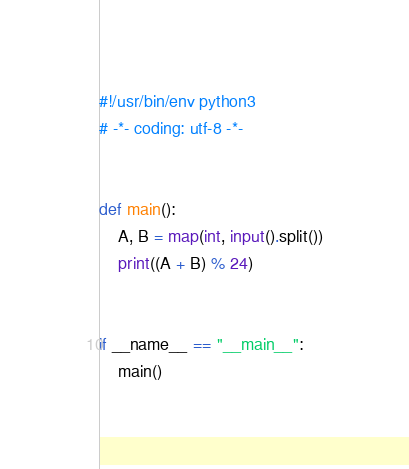<code> <loc_0><loc_0><loc_500><loc_500><_Python_>#!/usr/bin/env python3
# -*- coding: utf-8 -*-


def main():
    A, B = map(int, input().split())
    print((A + B) % 24)


if __name__ == "__main__":
    main()
</code> 